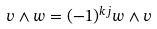Convert formula to latex. <formula><loc_0><loc_0><loc_500><loc_500>v \wedge w = ( - 1 ) ^ { k j } w \wedge v</formula> 